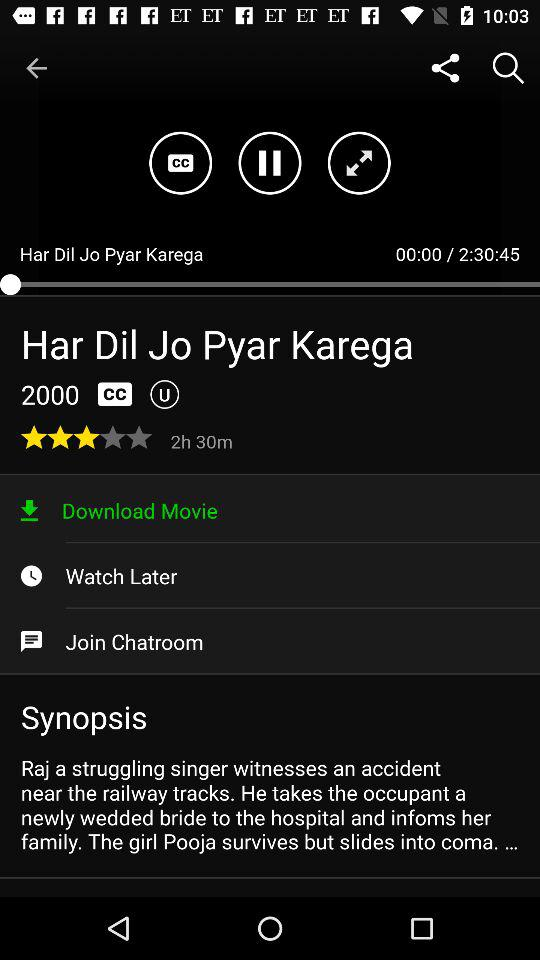What year was the movie released? The movie was released in 2000. 